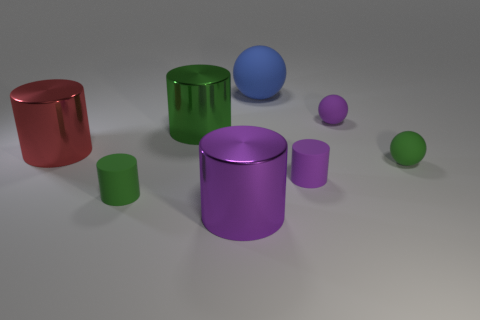Subtract all red cylinders. How many cylinders are left? 4 Subtract all green matte cylinders. How many cylinders are left? 4 Subtract all gray cylinders. Subtract all brown spheres. How many cylinders are left? 5 Add 1 green rubber balls. How many objects exist? 9 Subtract all cylinders. How many objects are left? 3 Add 6 small purple things. How many small purple things exist? 8 Subtract 0 blue cylinders. How many objects are left? 8 Subtract all green balls. Subtract all small green rubber cylinders. How many objects are left? 6 Add 6 small purple spheres. How many small purple spheres are left? 7 